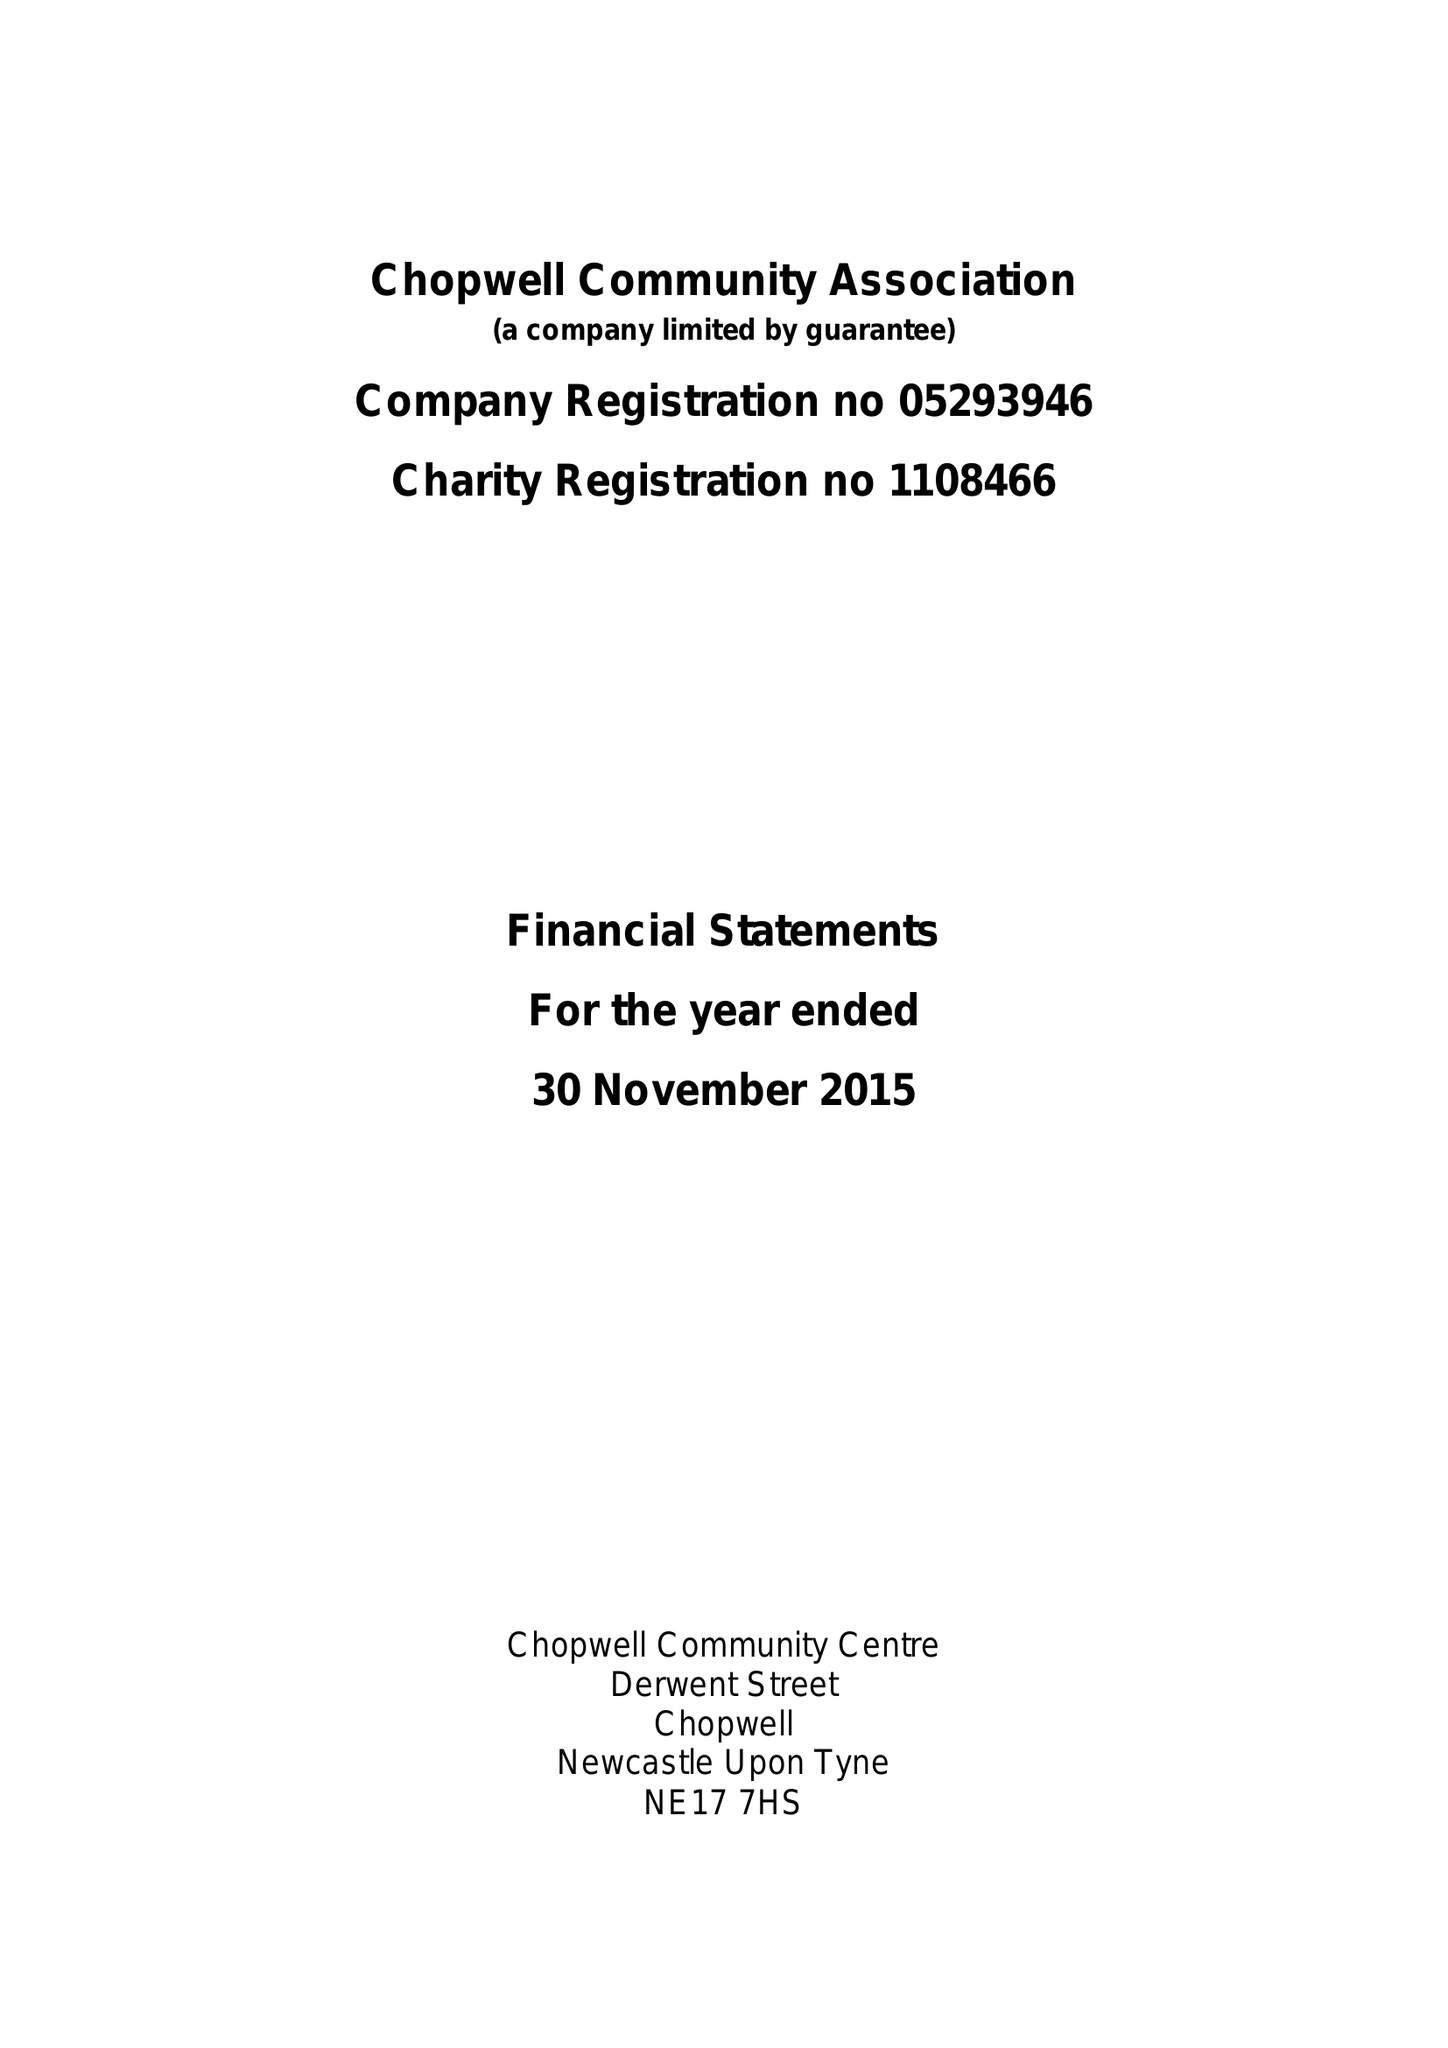What is the value for the income_annually_in_british_pounds?
Answer the question using a single word or phrase. 41692.00 